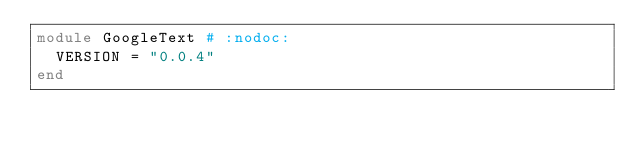Convert code to text. <code><loc_0><loc_0><loc_500><loc_500><_Ruby_>module GoogleText # :nodoc:
  VERSION = "0.0.4"
end</code> 